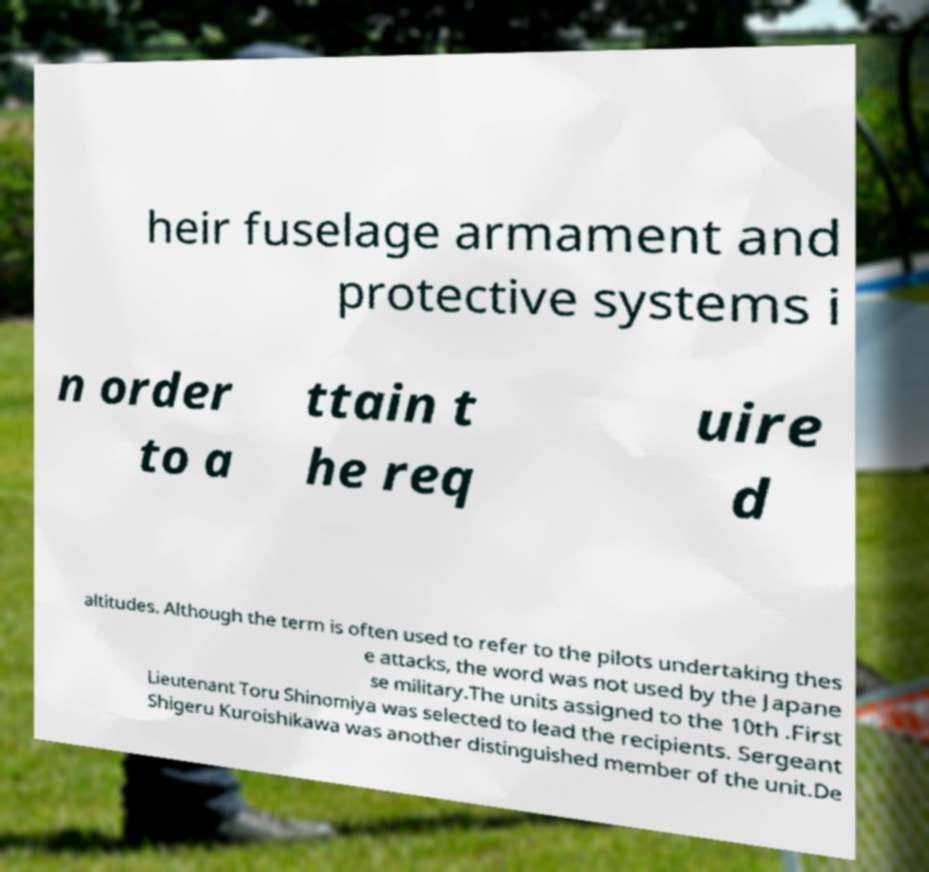Please read and relay the text visible in this image. What does it say? heir fuselage armament and protective systems i n order to a ttain t he req uire d altitudes. Although the term is often used to refer to the pilots undertaking thes e attacks, the word was not used by the Japane se military.The units assigned to the 10th .First Lieutenant Toru Shinomiya was selected to lead the recipients. Sergeant Shigeru Kuroishikawa was another distinguished member of the unit.De 